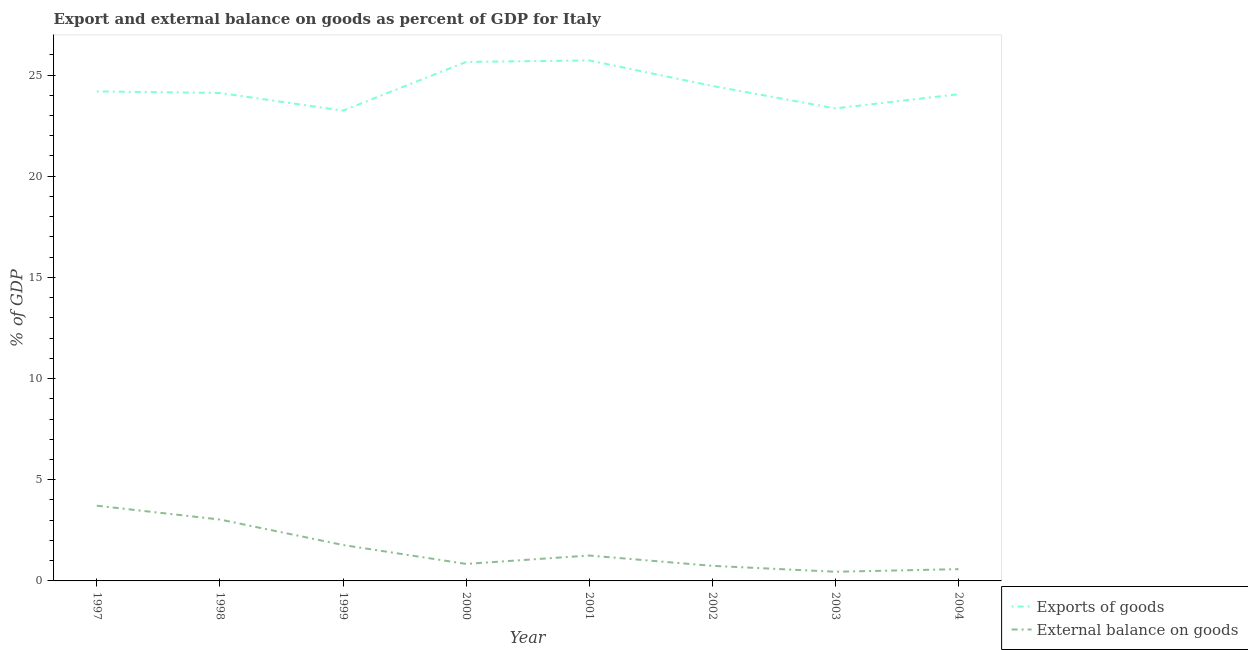How many different coloured lines are there?
Your answer should be very brief. 2. What is the export of goods as percentage of gdp in 1997?
Make the answer very short. 24.19. Across all years, what is the maximum export of goods as percentage of gdp?
Offer a terse response. 25.72. Across all years, what is the minimum external balance on goods as percentage of gdp?
Provide a succinct answer. 0.45. In which year was the external balance on goods as percentage of gdp maximum?
Your answer should be very brief. 1997. In which year was the external balance on goods as percentage of gdp minimum?
Your answer should be very brief. 2003. What is the total external balance on goods as percentage of gdp in the graph?
Give a very brief answer. 12.4. What is the difference between the external balance on goods as percentage of gdp in 1999 and that in 2001?
Your answer should be very brief. 0.52. What is the difference between the export of goods as percentage of gdp in 2003 and the external balance on goods as percentage of gdp in 2000?
Provide a short and direct response. 22.51. What is the average export of goods as percentage of gdp per year?
Provide a succinct answer. 24.35. In the year 2003, what is the difference between the export of goods as percentage of gdp and external balance on goods as percentage of gdp?
Make the answer very short. 22.9. What is the ratio of the export of goods as percentage of gdp in 1998 to that in 2002?
Give a very brief answer. 0.99. What is the difference between the highest and the second highest external balance on goods as percentage of gdp?
Your response must be concise. 0.68. What is the difference between the highest and the lowest external balance on goods as percentage of gdp?
Ensure brevity in your answer.  3.26. In how many years, is the external balance on goods as percentage of gdp greater than the average external balance on goods as percentage of gdp taken over all years?
Your response must be concise. 3. Is the sum of the external balance on goods as percentage of gdp in 2003 and 2004 greater than the maximum export of goods as percentage of gdp across all years?
Give a very brief answer. No. How many lines are there?
Offer a terse response. 2. Are the values on the major ticks of Y-axis written in scientific E-notation?
Your answer should be compact. No. Does the graph contain grids?
Ensure brevity in your answer.  No. Where does the legend appear in the graph?
Provide a succinct answer. Bottom right. How many legend labels are there?
Your response must be concise. 2. How are the legend labels stacked?
Ensure brevity in your answer.  Vertical. What is the title of the graph?
Give a very brief answer. Export and external balance on goods as percent of GDP for Italy. Does "Net savings(excluding particulate emission damage)" appear as one of the legend labels in the graph?
Your answer should be compact. No. What is the label or title of the X-axis?
Your answer should be compact. Year. What is the label or title of the Y-axis?
Ensure brevity in your answer.  % of GDP. What is the % of GDP in Exports of goods in 1997?
Offer a terse response. 24.19. What is the % of GDP of External balance on goods in 1997?
Your answer should be compact. 3.72. What is the % of GDP of Exports of goods in 1998?
Your answer should be very brief. 24.11. What is the % of GDP in External balance on goods in 1998?
Your answer should be compact. 3.03. What is the % of GDP in Exports of goods in 1999?
Keep it short and to the point. 23.24. What is the % of GDP of External balance on goods in 1999?
Give a very brief answer. 1.78. What is the % of GDP in Exports of goods in 2000?
Keep it short and to the point. 25.65. What is the % of GDP in External balance on goods in 2000?
Your answer should be compact. 0.84. What is the % of GDP of Exports of goods in 2001?
Keep it short and to the point. 25.72. What is the % of GDP of External balance on goods in 2001?
Offer a very short reply. 1.25. What is the % of GDP in Exports of goods in 2002?
Make the answer very short. 24.46. What is the % of GDP of External balance on goods in 2002?
Provide a succinct answer. 0.75. What is the % of GDP of Exports of goods in 2003?
Your answer should be compact. 23.35. What is the % of GDP in External balance on goods in 2003?
Offer a very short reply. 0.45. What is the % of GDP in Exports of goods in 2004?
Offer a terse response. 24.05. What is the % of GDP in External balance on goods in 2004?
Ensure brevity in your answer.  0.58. Across all years, what is the maximum % of GDP of Exports of goods?
Offer a very short reply. 25.72. Across all years, what is the maximum % of GDP of External balance on goods?
Your answer should be compact. 3.72. Across all years, what is the minimum % of GDP in Exports of goods?
Make the answer very short. 23.24. Across all years, what is the minimum % of GDP in External balance on goods?
Your answer should be very brief. 0.45. What is the total % of GDP of Exports of goods in the graph?
Give a very brief answer. 194.78. What is the total % of GDP of External balance on goods in the graph?
Ensure brevity in your answer.  12.4. What is the difference between the % of GDP of Exports of goods in 1997 and that in 1998?
Keep it short and to the point. 0.08. What is the difference between the % of GDP in External balance on goods in 1997 and that in 1998?
Keep it short and to the point. 0.68. What is the difference between the % of GDP in Exports of goods in 1997 and that in 1999?
Give a very brief answer. 0.95. What is the difference between the % of GDP of External balance on goods in 1997 and that in 1999?
Offer a terse response. 1.94. What is the difference between the % of GDP in Exports of goods in 1997 and that in 2000?
Offer a very short reply. -1.46. What is the difference between the % of GDP in External balance on goods in 1997 and that in 2000?
Your response must be concise. 2.88. What is the difference between the % of GDP of Exports of goods in 1997 and that in 2001?
Give a very brief answer. -1.53. What is the difference between the % of GDP in External balance on goods in 1997 and that in 2001?
Your response must be concise. 2.46. What is the difference between the % of GDP of Exports of goods in 1997 and that in 2002?
Offer a terse response. -0.27. What is the difference between the % of GDP of External balance on goods in 1997 and that in 2002?
Make the answer very short. 2.97. What is the difference between the % of GDP of Exports of goods in 1997 and that in 2003?
Provide a succinct answer. 0.84. What is the difference between the % of GDP of External balance on goods in 1997 and that in 2003?
Your answer should be compact. 3.26. What is the difference between the % of GDP in Exports of goods in 1997 and that in 2004?
Your answer should be very brief. 0.14. What is the difference between the % of GDP in External balance on goods in 1997 and that in 2004?
Your answer should be compact. 3.14. What is the difference between the % of GDP in Exports of goods in 1998 and that in 1999?
Offer a very short reply. 0.87. What is the difference between the % of GDP in External balance on goods in 1998 and that in 1999?
Give a very brief answer. 1.26. What is the difference between the % of GDP in Exports of goods in 1998 and that in 2000?
Keep it short and to the point. -1.53. What is the difference between the % of GDP in External balance on goods in 1998 and that in 2000?
Keep it short and to the point. 2.19. What is the difference between the % of GDP of Exports of goods in 1998 and that in 2001?
Offer a terse response. -1.61. What is the difference between the % of GDP of External balance on goods in 1998 and that in 2001?
Your answer should be very brief. 1.78. What is the difference between the % of GDP in Exports of goods in 1998 and that in 2002?
Provide a succinct answer. -0.35. What is the difference between the % of GDP of External balance on goods in 1998 and that in 2002?
Offer a very short reply. 2.29. What is the difference between the % of GDP in Exports of goods in 1998 and that in 2003?
Ensure brevity in your answer.  0.76. What is the difference between the % of GDP of External balance on goods in 1998 and that in 2003?
Your response must be concise. 2.58. What is the difference between the % of GDP of Exports of goods in 1998 and that in 2004?
Offer a terse response. 0.06. What is the difference between the % of GDP of External balance on goods in 1998 and that in 2004?
Offer a very short reply. 2.45. What is the difference between the % of GDP of Exports of goods in 1999 and that in 2000?
Your response must be concise. -2.41. What is the difference between the % of GDP of External balance on goods in 1999 and that in 2000?
Make the answer very short. 0.93. What is the difference between the % of GDP in Exports of goods in 1999 and that in 2001?
Your answer should be compact. -2.48. What is the difference between the % of GDP of External balance on goods in 1999 and that in 2001?
Make the answer very short. 0.52. What is the difference between the % of GDP of Exports of goods in 1999 and that in 2002?
Provide a succinct answer. -1.22. What is the difference between the % of GDP of External balance on goods in 1999 and that in 2002?
Offer a terse response. 1.03. What is the difference between the % of GDP of Exports of goods in 1999 and that in 2003?
Give a very brief answer. -0.11. What is the difference between the % of GDP in External balance on goods in 1999 and that in 2003?
Provide a short and direct response. 1.32. What is the difference between the % of GDP in Exports of goods in 1999 and that in 2004?
Provide a short and direct response. -0.81. What is the difference between the % of GDP of External balance on goods in 1999 and that in 2004?
Your response must be concise. 1.19. What is the difference between the % of GDP in Exports of goods in 2000 and that in 2001?
Make the answer very short. -0.07. What is the difference between the % of GDP in External balance on goods in 2000 and that in 2001?
Give a very brief answer. -0.41. What is the difference between the % of GDP in Exports of goods in 2000 and that in 2002?
Offer a terse response. 1.19. What is the difference between the % of GDP of External balance on goods in 2000 and that in 2002?
Ensure brevity in your answer.  0.1. What is the difference between the % of GDP in Exports of goods in 2000 and that in 2003?
Offer a very short reply. 2.3. What is the difference between the % of GDP of External balance on goods in 2000 and that in 2003?
Keep it short and to the point. 0.39. What is the difference between the % of GDP of Exports of goods in 2000 and that in 2004?
Offer a very short reply. 1.6. What is the difference between the % of GDP of External balance on goods in 2000 and that in 2004?
Give a very brief answer. 0.26. What is the difference between the % of GDP of Exports of goods in 2001 and that in 2002?
Ensure brevity in your answer.  1.26. What is the difference between the % of GDP in External balance on goods in 2001 and that in 2002?
Make the answer very short. 0.51. What is the difference between the % of GDP of Exports of goods in 2001 and that in 2003?
Offer a terse response. 2.37. What is the difference between the % of GDP of External balance on goods in 2001 and that in 2003?
Provide a succinct answer. 0.8. What is the difference between the % of GDP in Exports of goods in 2001 and that in 2004?
Provide a succinct answer. 1.67. What is the difference between the % of GDP of External balance on goods in 2001 and that in 2004?
Make the answer very short. 0.67. What is the difference between the % of GDP of Exports of goods in 2002 and that in 2003?
Offer a terse response. 1.11. What is the difference between the % of GDP in External balance on goods in 2002 and that in 2003?
Provide a short and direct response. 0.29. What is the difference between the % of GDP of Exports of goods in 2002 and that in 2004?
Give a very brief answer. 0.41. What is the difference between the % of GDP of External balance on goods in 2002 and that in 2004?
Offer a very short reply. 0.16. What is the difference between the % of GDP of Exports of goods in 2003 and that in 2004?
Your answer should be compact. -0.7. What is the difference between the % of GDP of External balance on goods in 2003 and that in 2004?
Offer a very short reply. -0.13. What is the difference between the % of GDP of Exports of goods in 1997 and the % of GDP of External balance on goods in 1998?
Keep it short and to the point. 21.16. What is the difference between the % of GDP in Exports of goods in 1997 and the % of GDP in External balance on goods in 1999?
Your response must be concise. 22.42. What is the difference between the % of GDP of Exports of goods in 1997 and the % of GDP of External balance on goods in 2000?
Your response must be concise. 23.35. What is the difference between the % of GDP of Exports of goods in 1997 and the % of GDP of External balance on goods in 2001?
Provide a succinct answer. 22.94. What is the difference between the % of GDP of Exports of goods in 1997 and the % of GDP of External balance on goods in 2002?
Your response must be concise. 23.45. What is the difference between the % of GDP of Exports of goods in 1997 and the % of GDP of External balance on goods in 2003?
Offer a terse response. 23.74. What is the difference between the % of GDP of Exports of goods in 1997 and the % of GDP of External balance on goods in 2004?
Your response must be concise. 23.61. What is the difference between the % of GDP in Exports of goods in 1998 and the % of GDP in External balance on goods in 1999?
Offer a terse response. 22.34. What is the difference between the % of GDP of Exports of goods in 1998 and the % of GDP of External balance on goods in 2000?
Provide a short and direct response. 23.27. What is the difference between the % of GDP in Exports of goods in 1998 and the % of GDP in External balance on goods in 2001?
Provide a succinct answer. 22.86. What is the difference between the % of GDP of Exports of goods in 1998 and the % of GDP of External balance on goods in 2002?
Offer a very short reply. 23.37. What is the difference between the % of GDP of Exports of goods in 1998 and the % of GDP of External balance on goods in 2003?
Give a very brief answer. 23.66. What is the difference between the % of GDP of Exports of goods in 1998 and the % of GDP of External balance on goods in 2004?
Keep it short and to the point. 23.53. What is the difference between the % of GDP in Exports of goods in 1999 and the % of GDP in External balance on goods in 2000?
Provide a succinct answer. 22.4. What is the difference between the % of GDP of Exports of goods in 1999 and the % of GDP of External balance on goods in 2001?
Provide a short and direct response. 21.99. What is the difference between the % of GDP in Exports of goods in 1999 and the % of GDP in External balance on goods in 2002?
Ensure brevity in your answer.  22.5. What is the difference between the % of GDP of Exports of goods in 1999 and the % of GDP of External balance on goods in 2003?
Your response must be concise. 22.79. What is the difference between the % of GDP of Exports of goods in 1999 and the % of GDP of External balance on goods in 2004?
Your answer should be compact. 22.66. What is the difference between the % of GDP of Exports of goods in 2000 and the % of GDP of External balance on goods in 2001?
Your answer should be very brief. 24.39. What is the difference between the % of GDP of Exports of goods in 2000 and the % of GDP of External balance on goods in 2002?
Your response must be concise. 24.9. What is the difference between the % of GDP in Exports of goods in 2000 and the % of GDP in External balance on goods in 2003?
Ensure brevity in your answer.  25.2. What is the difference between the % of GDP in Exports of goods in 2000 and the % of GDP in External balance on goods in 2004?
Give a very brief answer. 25.07. What is the difference between the % of GDP in Exports of goods in 2001 and the % of GDP in External balance on goods in 2002?
Provide a succinct answer. 24.98. What is the difference between the % of GDP in Exports of goods in 2001 and the % of GDP in External balance on goods in 2003?
Provide a short and direct response. 25.27. What is the difference between the % of GDP of Exports of goods in 2001 and the % of GDP of External balance on goods in 2004?
Your answer should be very brief. 25.14. What is the difference between the % of GDP of Exports of goods in 2002 and the % of GDP of External balance on goods in 2003?
Provide a succinct answer. 24.01. What is the difference between the % of GDP of Exports of goods in 2002 and the % of GDP of External balance on goods in 2004?
Provide a short and direct response. 23.88. What is the difference between the % of GDP of Exports of goods in 2003 and the % of GDP of External balance on goods in 2004?
Offer a very short reply. 22.77. What is the average % of GDP of Exports of goods per year?
Provide a short and direct response. 24.35. What is the average % of GDP in External balance on goods per year?
Your answer should be compact. 1.55. In the year 1997, what is the difference between the % of GDP of Exports of goods and % of GDP of External balance on goods?
Provide a succinct answer. 20.47. In the year 1998, what is the difference between the % of GDP in Exports of goods and % of GDP in External balance on goods?
Give a very brief answer. 21.08. In the year 1999, what is the difference between the % of GDP of Exports of goods and % of GDP of External balance on goods?
Offer a very short reply. 21.47. In the year 2000, what is the difference between the % of GDP in Exports of goods and % of GDP in External balance on goods?
Offer a very short reply. 24.81. In the year 2001, what is the difference between the % of GDP of Exports of goods and % of GDP of External balance on goods?
Ensure brevity in your answer.  24.47. In the year 2002, what is the difference between the % of GDP in Exports of goods and % of GDP in External balance on goods?
Your answer should be very brief. 23.72. In the year 2003, what is the difference between the % of GDP in Exports of goods and % of GDP in External balance on goods?
Your answer should be very brief. 22.9. In the year 2004, what is the difference between the % of GDP of Exports of goods and % of GDP of External balance on goods?
Offer a very short reply. 23.47. What is the ratio of the % of GDP in External balance on goods in 1997 to that in 1998?
Make the answer very short. 1.23. What is the ratio of the % of GDP in Exports of goods in 1997 to that in 1999?
Make the answer very short. 1.04. What is the ratio of the % of GDP of External balance on goods in 1997 to that in 1999?
Your answer should be very brief. 2.09. What is the ratio of the % of GDP in Exports of goods in 1997 to that in 2000?
Ensure brevity in your answer.  0.94. What is the ratio of the % of GDP of External balance on goods in 1997 to that in 2000?
Keep it short and to the point. 4.42. What is the ratio of the % of GDP in Exports of goods in 1997 to that in 2001?
Your answer should be compact. 0.94. What is the ratio of the % of GDP of External balance on goods in 1997 to that in 2001?
Provide a short and direct response. 2.96. What is the ratio of the % of GDP of Exports of goods in 1997 to that in 2002?
Keep it short and to the point. 0.99. What is the ratio of the % of GDP in External balance on goods in 1997 to that in 2002?
Your answer should be very brief. 4.99. What is the ratio of the % of GDP in Exports of goods in 1997 to that in 2003?
Provide a succinct answer. 1.04. What is the ratio of the % of GDP of External balance on goods in 1997 to that in 2003?
Your answer should be very brief. 8.21. What is the ratio of the % of GDP in Exports of goods in 1997 to that in 2004?
Make the answer very short. 1.01. What is the ratio of the % of GDP of External balance on goods in 1997 to that in 2004?
Keep it short and to the point. 6.39. What is the ratio of the % of GDP in Exports of goods in 1998 to that in 1999?
Provide a succinct answer. 1.04. What is the ratio of the % of GDP in External balance on goods in 1998 to that in 1999?
Keep it short and to the point. 1.71. What is the ratio of the % of GDP of Exports of goods in 1998 to that in 2000?
Ensure brevity in your answer.  0.94. What is the ratio of the % of GDP in External balance on goods in 1998 to that in 2000?
Your answer should be compact. 3.61. What is the ratio of the % of GDP of External balance on goods in 1998 to that in 2001?
Your answer should be very brief. 2.42. What is the ratio of the % of GDP in Exports of goods in 1998 to that in 2002?
Your answer should be very brief. 0.99. What is the ratio of the % of GDP in External balance on goods in 1998 to that in 2002?
Offer a very short reply. 4.07. What is the ratio of the % of GDP of Exports of goods in 1998 to that in 2003?
Keep it short and to the point. 1.03. What is the ratio of the % of GDP of External balance on goods in 1998 to that in 2003?
Provide a short and direct response. 6.7. What is the ratio of the % of GDP in Exports of goods in 1998 to that in 2004?
Your answer should be compact. 1. What is the ratio of the % of GDP of External balance on goods in 1998 to that in 2004?
Provide a short and direct response. 5.21. What is the ratio of the % of GDP of Exports of goods in 1999 to that in 2000?
Keep it short and to the point. 0.91. What is the ratio of the % of GDP in External balance on goods in 1999 to that in 2000?
Provide a succinct answer. 2.11. What is the ratio of the % of GDP of Exports of goods in 1999 to that in 2001?
Provide a short and direct response. 0.9. What is the ratio of the % of GDP in External balance on goods in 1999 to that in 2001?
Keep it short and to the point. 1.41. What is the ratio of the % of GDP of Exports of goods in 1999 to that in 2002?
Keep it short and to the point. 0.95. What is the ratio of the % of GDP of External balance on goods in 1999 to that in 2002?
Your answer should be very brief. 2.38. What is the ratio of the % of GDP in External balance on goods in 1999 to that in 2003?
Give a very brief answer. 3.92. What is the ratio of the % of GDP of Exports of goods in 1999 to that in 2004?
Offer a terse response. 0.97. What is the ratio of the % of GDP in External balance on goods in 1999 to that in 2004?
Your answer should be very brief. 3.05. What is the ratio of the % of GDP in External balance on goods in 2000 to that in 2001?
Give a very brief answer. 0.67. What is the ratio of the % of GDP in Exports of goods in 2000 to that in 2002?
Your response must be concise. 1.05. What is the ratio of the % of GDP of External balance on goods in 2000 to that in 2002?
Give a very brief answer. 1.13. What is the ratio of the % of GDP in Exports of goods in 2000 to that in 2003?
Your response must be concise. 1.1. What is the ratio of the % of GDP in External balance on goods in 2000 to that in 2003?
Give a very brief answer. 1.86. What is the ratio of the % of GDP in Exports of goods in 2000 to that in 2004?
Your answer should be very brief. 1.07. What is the ratio of the % of GDP of External balance on goods in 2000 to that in 2004?
Provide a succinct answer. 1.44. What is the ratio of the % of GDP of Exports of goods in 2001 to that in 2002?
Your answer should be compact. 1.05. What is the ratio of the % of GDP in External balance on goods in 2001 to that in 2002?
Offer a very short reply. 1.68. What is the ratio of the % of GDP in Exports of goods in 2001 to that in 2003?
Ensure brevity in your answer.  1.1. What is the ratio of the % of GDP of External balance on goods in 2001 to that in 2003?
Offer a terse response. 2.77. What is the ratio of the % of GDP of Exports of goods in 2001 to that in 2004?
Make the answer very short. 1.07. What is the ratio of the % of GDP of External balance on goods in 2001 to that in 2004?
Ensure brevity in your answer.  2.16. What is the ratio of the % of GDP of Exports of goods in 2002 to that in 2003?
Give a very brief answer. 1.05. What is the ratio of the % of GDP of External balance on goods in 2002 to that in 2003?
Ensure brevity in your answer.  1.65. What is the ratio of the % of GDP of External balance on goods in 2002 to that in 2004?
Offer a terse response. 1.28. What is the ratio of the % of GDP in Exports of goods in 2003 to that in 2004?
Provide a short and direct response. 0.97. What is the ratio of the % of GDP in External balance on goods in 2003 to that in 2004?
Make the answer very short. 0.78. What is the difference between the highest and the second highest % of GDP in Exports of goods?
Offer a terse response. 0.07. What is the difference between the highest and the second highest % of GDP of External balance on goods?
Keep it short and to the point. 0.68. What is the difference between the highest and the lowest % of GDP of Exports of goods?
Offer a terse response. 2.48. What is the difference between the highest and the lowest % of GDP in External balance on goods?
Your response must be concise. 3.26. 